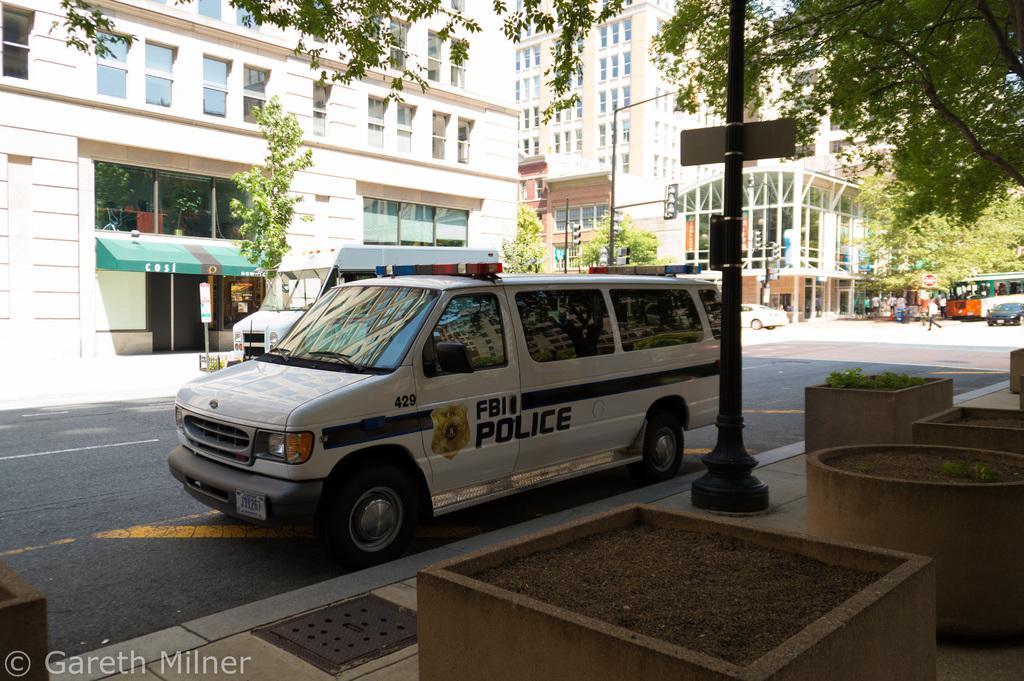How would you summarize this image in a sentence or two? In this picture I can see there are is a car parked on the road and in the backdrop I can see there are trees, buildings and there is a road. 